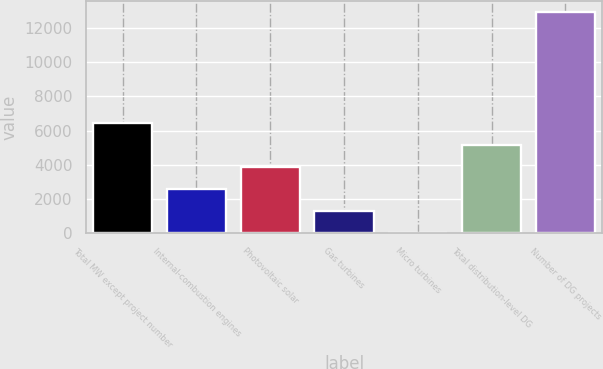Convert chart. <chart><loc_0><loc_0><loc_500><loc_500><bar_chart><fcel>Total MW except project number<fcel>Internal-combustion engines<fcel>Photovoltaic solar<fcel>Gas turbines<fcel>Micro turbines<fcel>Total distribution-level DG<fcel>Number of DG projects<nl><fcel>6469<fcel>2593.6<fcel>3885.4<fcel>1301.8<fcel>10<fcel>5177.2<fcel>12928<nl></chart> 